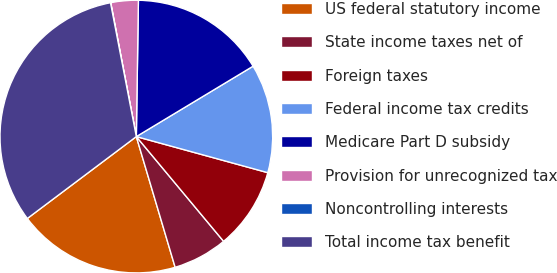<chart> <loc_0><loc_0><loc_500><loc_500><pie_chart><fcel>US federal statutory income<fcel>State income taxes net of<fcel>Foreign taxes<fcel>Federal income tax credits<fcel>Medicare Part D subsidy<fcel>Provision for unrecognized tax<fcel>Noncontrolling interests<fcel>Total income tax benefit<nl><fcel>19.34%<fcel>6.46%<fcel>9.68%<fcel>12.9%<fcel>16.12%<fcel>3.25%<fcel>0.03%<fcel>32.22%<nl></chart> 